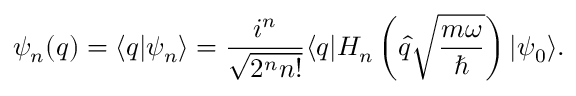<formula> <loc_0><loc_0><loc_500><loc_500>\psi _ { n } ( q ) = \langle q | \psi _ { n } \rangle = \frac { i ^ { n } } { \sqrt { 2 ^ { n } n ! } } \langle q | H _ { n } \left ( \hat { q } \sqrt { \frac { m \omega } { } } \right ) | \psi _ { 0 } \rangle .</formula> 